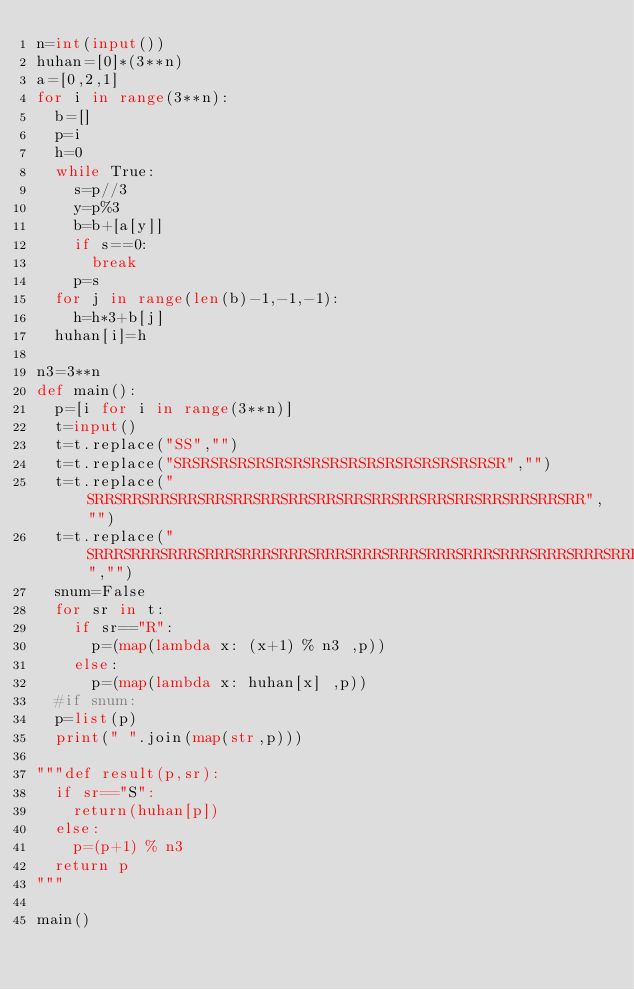<code> <loc_0><loc_0><loc_500><loc_500><_Python_>n=int(input())
huhan=[0]*(3**n)
a=[0,2,1]
for i in range(3**n):
  b=[]
  p=i
  h=0
  while True:
    s=p//3
    y=p%3
    b=b+[a[y]]
    if s==0:
      break
    p=s
  for j in range(len(b)-1,-1,-1):
    h=h*3+b[j]
  huhan[i]=h

n3=3**n
def main():
  p=[i for i in range(3**n)]
  t=input()
  t=t.replace("SS","")
  t=t.replace("SRSRSRSRSRSRSRSRSRSRSRSRSRSRSRSRSRSR","")
  t=t.replace("SRRSRRSRRSRRSRRSRRSRRSRRSRRSRRSRRSRRSRRSRRSRRSRRSRRSRR","")
  t=t.replace("SRRRSRRRSRRRSRRRSRRRSRRRSRRRSRRRSRRRSRRRSRRRSRRRSRRRSRRRSRRRSRRRSRRRSRRR","")  
  snum=False
  for sr in t:
    if sr=="R":
      p=(map(lambda x: (x+1) % n3 ,p))
    else:
      p=(map(lambda x: huhan[x] ,p))
  #if snum:
  p=list(p)
  print(" ".join(map(str,p)))
    
"""def result(p,sr):
  if sr=="S":
    return(huhan[p])
  else:
    p=(p+1) % n3
  return p
""" 
    
main()</code> 